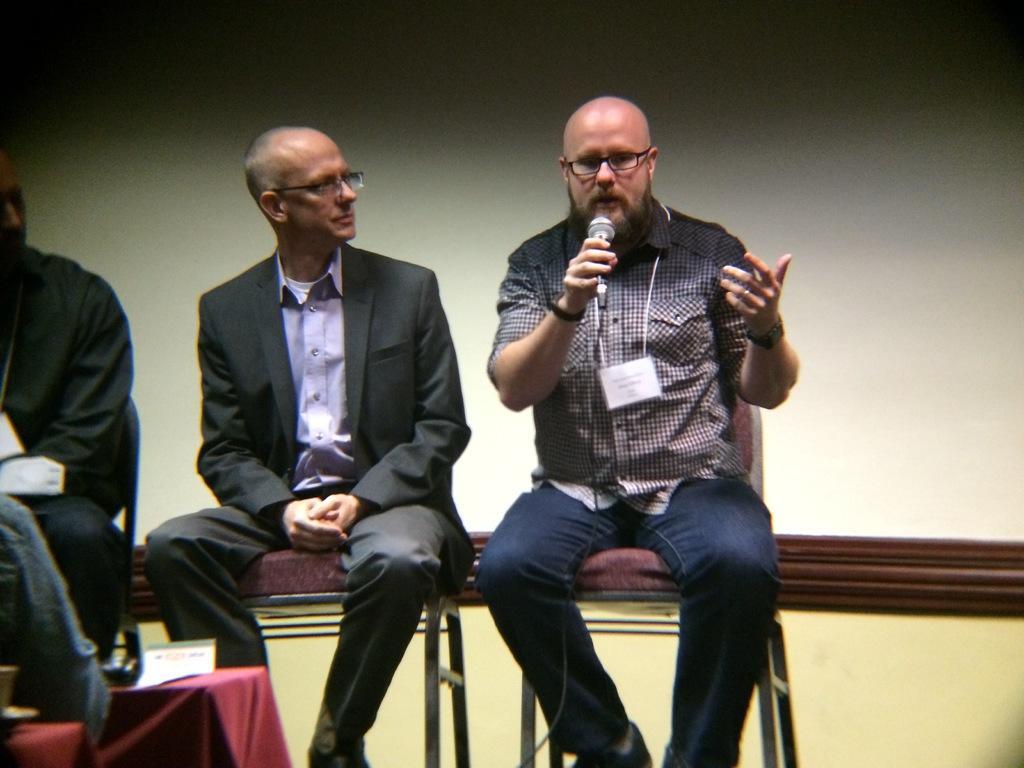Could you give a brief overview of what you see in this image? In this image we can see a man wearing the glasses and also the card and holding the mike and sitting on the chair. We can also see the people sitting. We can see the table which is covered with the cloth and on the table we can see the card. In the background we can see the wall. 